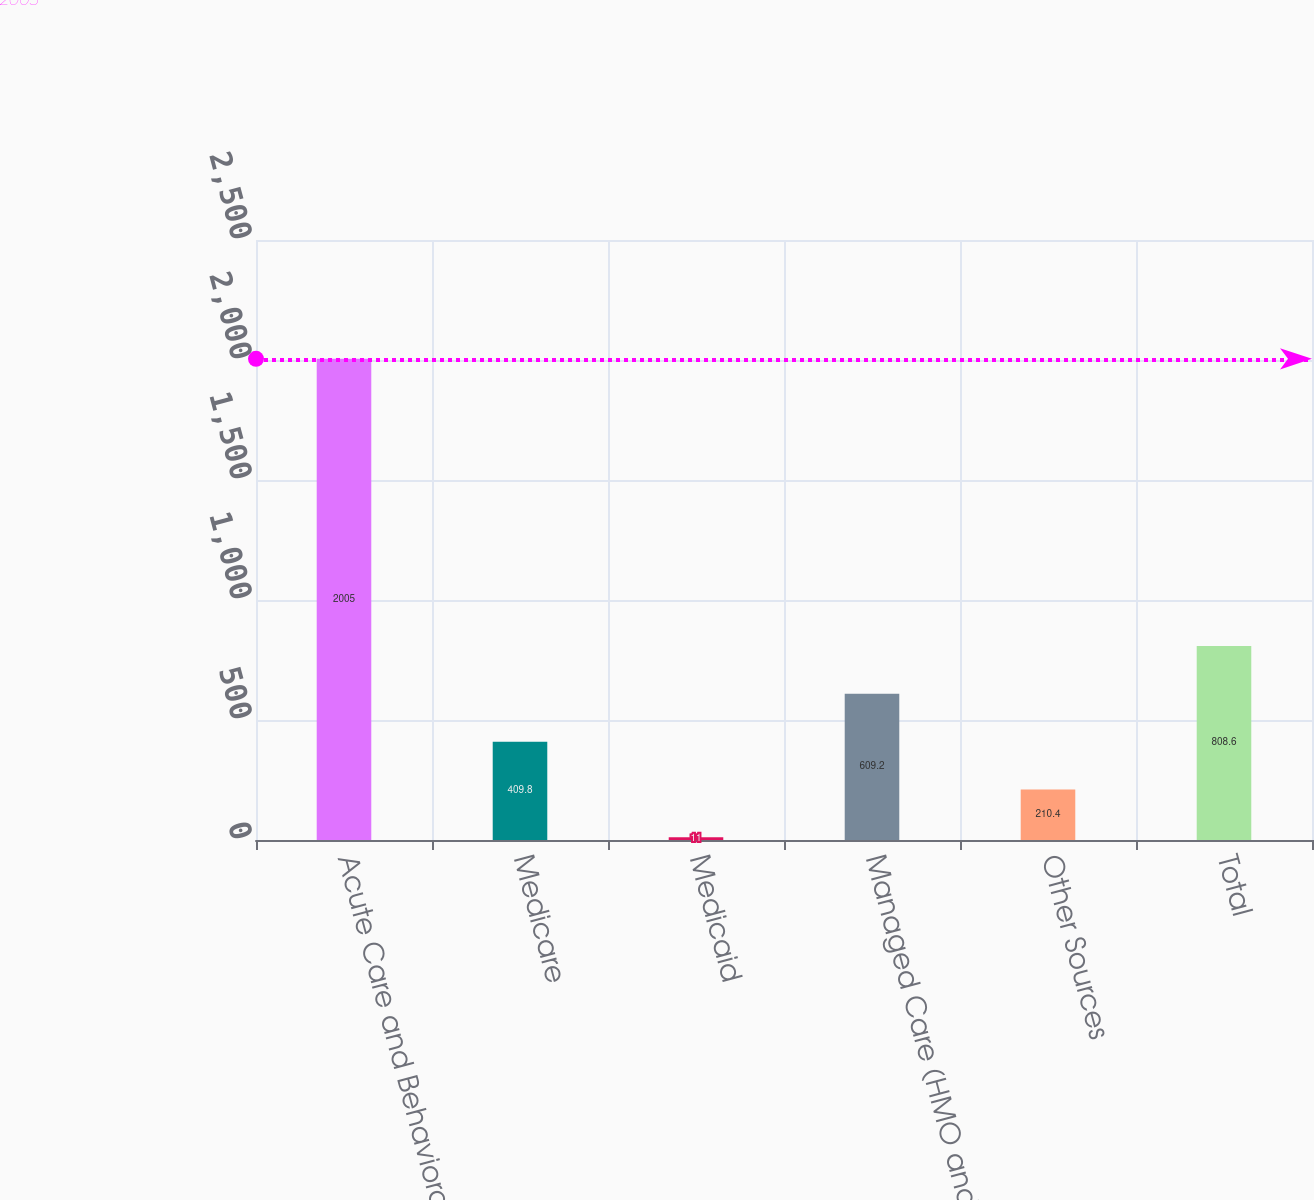<chart> <loc_0><loc_0><loc_500><loc_500><bar_chart><fcel>Acute Care and Behavioral<fcel>Medicare<fcel>Medicaid<fcel>Managed Care (HMO and PPOs)<fcel>Other Sources<fcel>Total<nl><fcel>2005<fcel>409.8<fcel>11<fcel>609.2<fcel>210.4<fcel>808.6<nl></chart> 